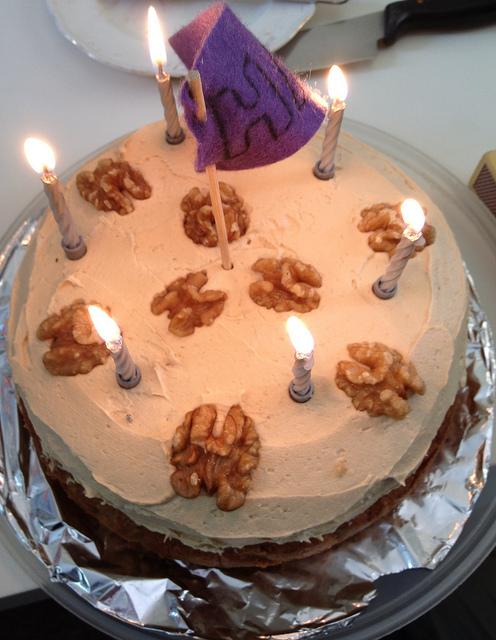What color is the cake?
Write a very short answer. White. What kind of cake?
Keep it brief. Walnut. How many candles?
Answer briefly. 6. What kind of nuts are on the cake?
Short answer required. Walnuts. 